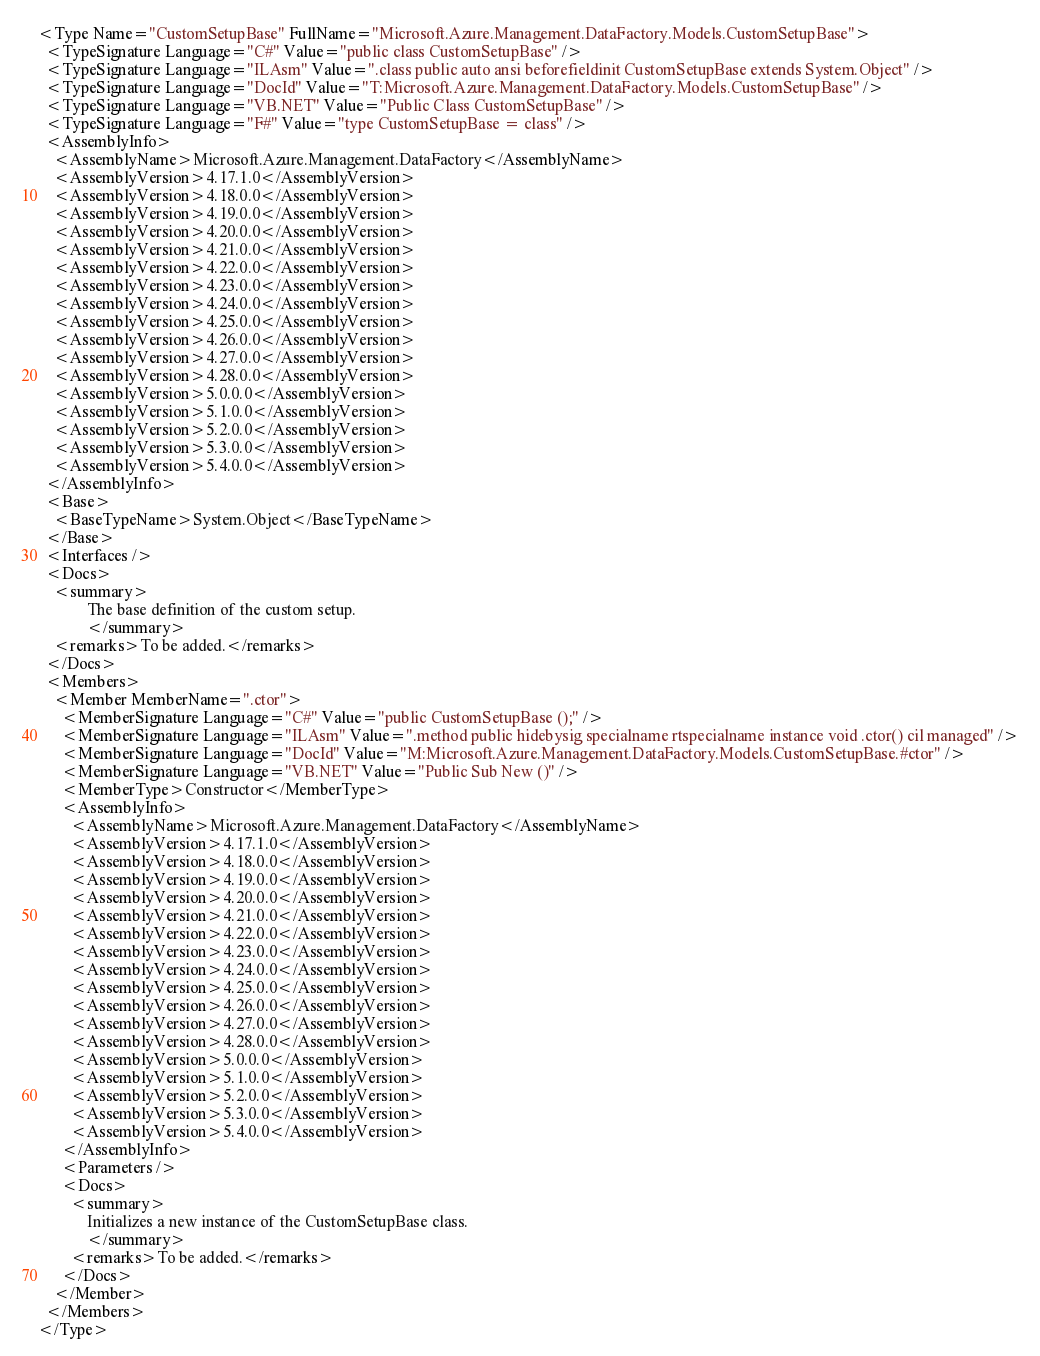<code> <loc_0><loc_0><loc_500><loc_500><_XML_><Type Name="CustomSetupBase" FullName="Microsoft.Azure.Management.DataFactory.Models.CustomSetupBase">
  <TypeSignature Language="C#" Value="public class CustomSetupBase" />
  <TypeSignature Language="ILAsm" Value=".class public auto ansi beforefieldinit CustomSetupBase extends System.Object" />
  <TypeSignature Language="DocId" Value="T:Microsoft.Azure.Management.DataFactory.Models.CustomSetupBase" />
  <TypeSignature Language="VB.NET" Value="Public Class CustomSetupBase" />
  <TypeSignature Language="F#" Value="type CustomSetupBase = class" />
  <AssemblyInfo>
    <AssemblyName>Microsoft.Azure.Management.DataFactory</AssemblyName>
    <AssemblyVersion>4.17.1.0</AssemblyVersion>
    <AssemblyVersion>4.18.0.0</AssemblyVersion>
    <AssemblyVersion>4.19.0.0</AssemblyVersion>
    <AssemblyVersion>4.20.0.0</AssemblyVersion>
    <AssemblyVersion>4.21.0.0</AssemblyVersion>
    <AssemblyVersion>4.22.0.0</AssemblyVersion>
    <AssemblyVersion>4.23.0.0</AssemblyVersion>
    <AssemblyVersion>4.24.0.0</AssemblyVersion>
    <AssemblyVersion>4.25.0.0</AssemblyVersion>
    <AssemblyVersion>4.26.0.0</AssemblyVersion>
    <AssemblyVersion>4.27.0.0</AssemblyVersion>
    <AssemblyVersion>4.28.0.0</AssemblyVersion>
    <AssemblyVersion>5.0.0.0</AssemblyVersion>
    <AssemblyVersion>5.1.0.0</AssemblyVersion>
    <AssemblyVersion>5.2.0.0</AssemblyVersion>
    <AssemblyVersion>5.3.0.0</AssemblyVersion>
    <AssemblyVersion>5.4.0.0</AssemblyVersion>
  </AssemblyInfo>
  <Base>
    <BaseTypeName>System.Object</BaseTypeName>
  </Base>
  <Interfaces />
  <Docs>
    <summary>
            The base definition of the custom setup.
            </summary>
    <remarks>To be added.</remarks>
  </Docs>
  <Members>
    <Member MemberName=".ctor">
      <MemberSignature Language="C#" Value="public CustomSetupBase ();" />
      <MemberSignature Language="ILAsm" Value=".method public hidebysig specialname rtspecialname instance void .ctor() cil managed" />
      <MemberSignature Language="DocId" Value="M:Microsoft.Azure.Management.DataFactory.Models.CustomSetupBase.#ctor" />
      <MemberSignature Language="VB.NET" Value="Public Sub New ()" />
      <MemberType>Constructor</MemberType>
      <AssemblyInfo>
        <AssemblyName>Microsoft.Azure.Management.DataFactory</AssemblyName>
        <AssemblyVersion>4.17.1.0</AssemblyVersion>
        <AssemblyVersion>4.18.0.0</AssemblyVersion>
        <AssemblyVersion>4.19.0.0</AssemblyVersion>
        <AssemblyVersion>4.20.0.0</AssemblyVersion>
        <AssemblyVersion>4.21.0.0</AssemblyVersion>
        <AssemblyVersion>4.22.0.0</AssemblyVersion>
        <AssemblyVersion>4.23.0.0</AssemblyVersion>
        <AssemblyVersion>4.24.0.0</AssemblyVersion>
        <AssemblyVersion>4.25.0.0</AssemblyVersion>
        <AssemblyVersion>4.26.0.0</AssemblyVersion>
        <AssemblyVersion>4.27.0.0</AssemblyVersion>
        <AssemblyVersion>4.28.0.0</AssemblyVersion>
        <AssemblyVersion>5.0.0.0</AssemblyVersion>
        <AssemblyVersion>5.1.0.0</AssemblyVersion>
        <AssemblyVersion>5.2.0.0</AssemblyVersion>
        <AssemblyVersion>5.3.0.0</AssemblyVersion>
        <AssemblyVersion>5.4.0.0</AssemblyVersion>
      </AssemblyInfo>
      <Parameters />
      <Docs>
        <summary>
            Initializes a new instance of the CustomSetupBase class.
            </summary>
        <remarks>To be added.</remarks>
      </Docs>
    </Member>
  </Members>
</Type>
</code> 